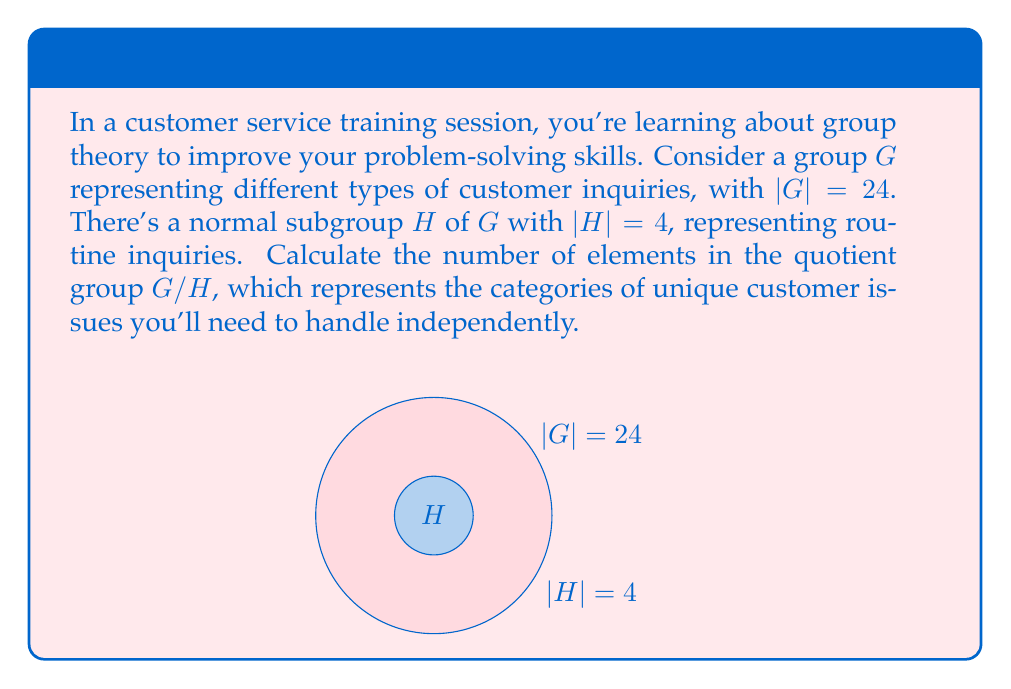Give your solution to this math problem. To find the number of elements in the quotient group $G/H$, we can use the following steps:

1. Recall the Lagrange's Theorem: For a finite group $G$ and a subgroup $H$ of $G$, the order of $H$ divides the order of $G$.

2. The quotient group $G/H$ consists of the left cosets of $H$ in $G$.

3. The number of elements in $G/H$ is equal to the index of $H$ in $G$, denoted as $[G:H]$.

4. The index $[G:H]$ is given by the formula:

   $$[G:H] = \frac{|G|}{|H|}$$

5. We are given:
   $|G| = 24$ (order of the group $G$)
   $|H| = 4$ (order of the subgroup $H$)

6. Substituting these values into the formula:

   $$[G:H] = \frac{|G|}{|H|} = \frac{24}{4} = 6$$

Therefore, the quotient group $G/H$ has 6 elements.
Answer: 6 